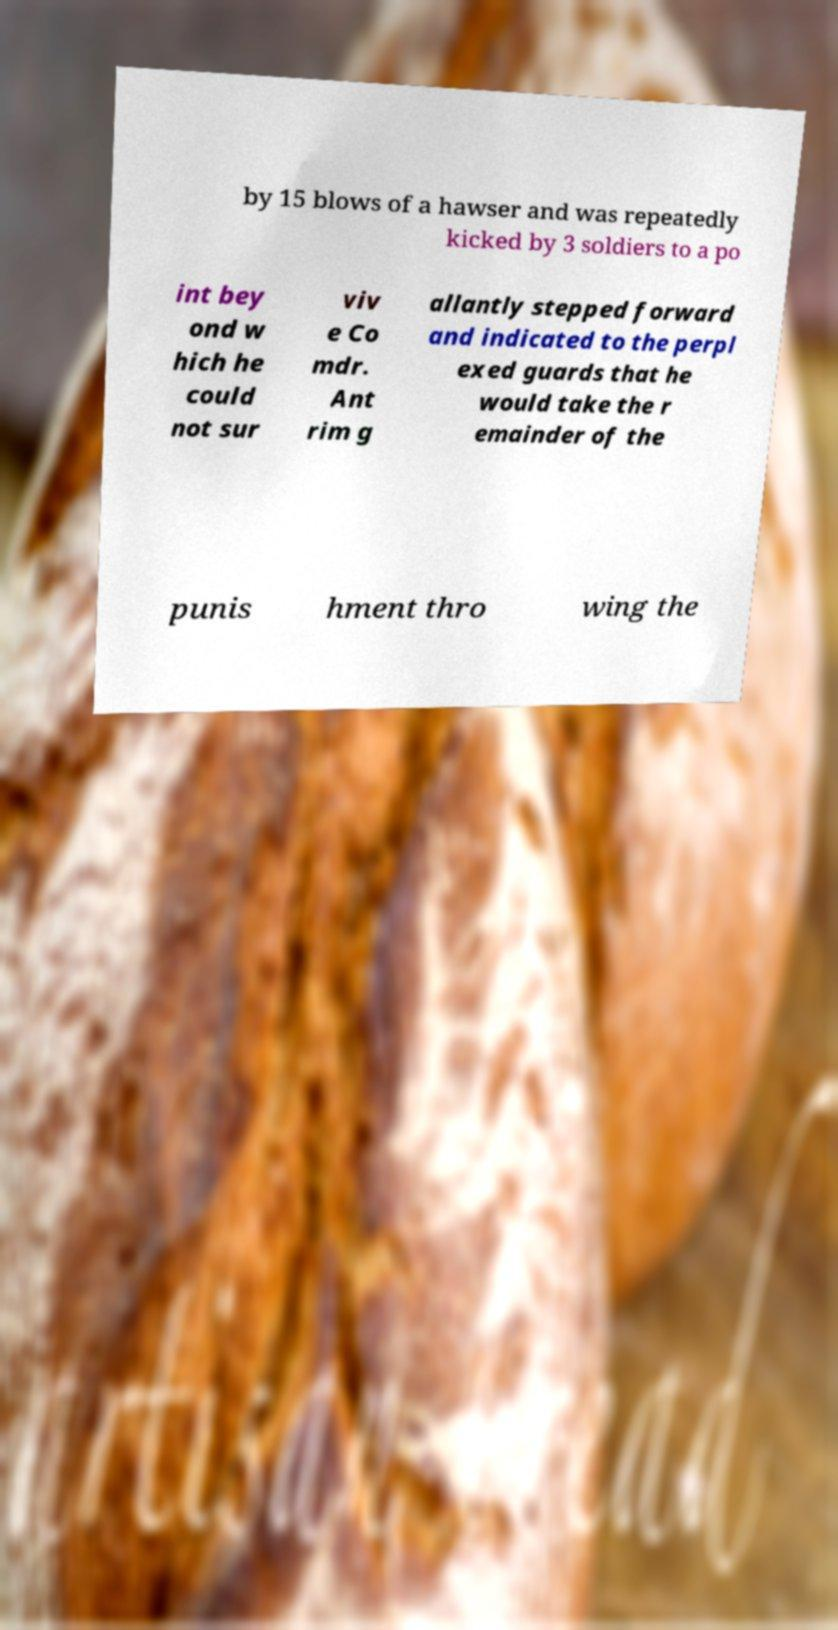Please read and relay the text visible in this image. What does it say? by 15 blows of a hawser and was repeatedly kicked by 3 soldiers to a po int bey ond w hich he could not sur viv e Co mdr. Ant rim g allantly stepped forward and indicated to the perpl exed guards that he would take the r emainder of the punis hment thro wing the 